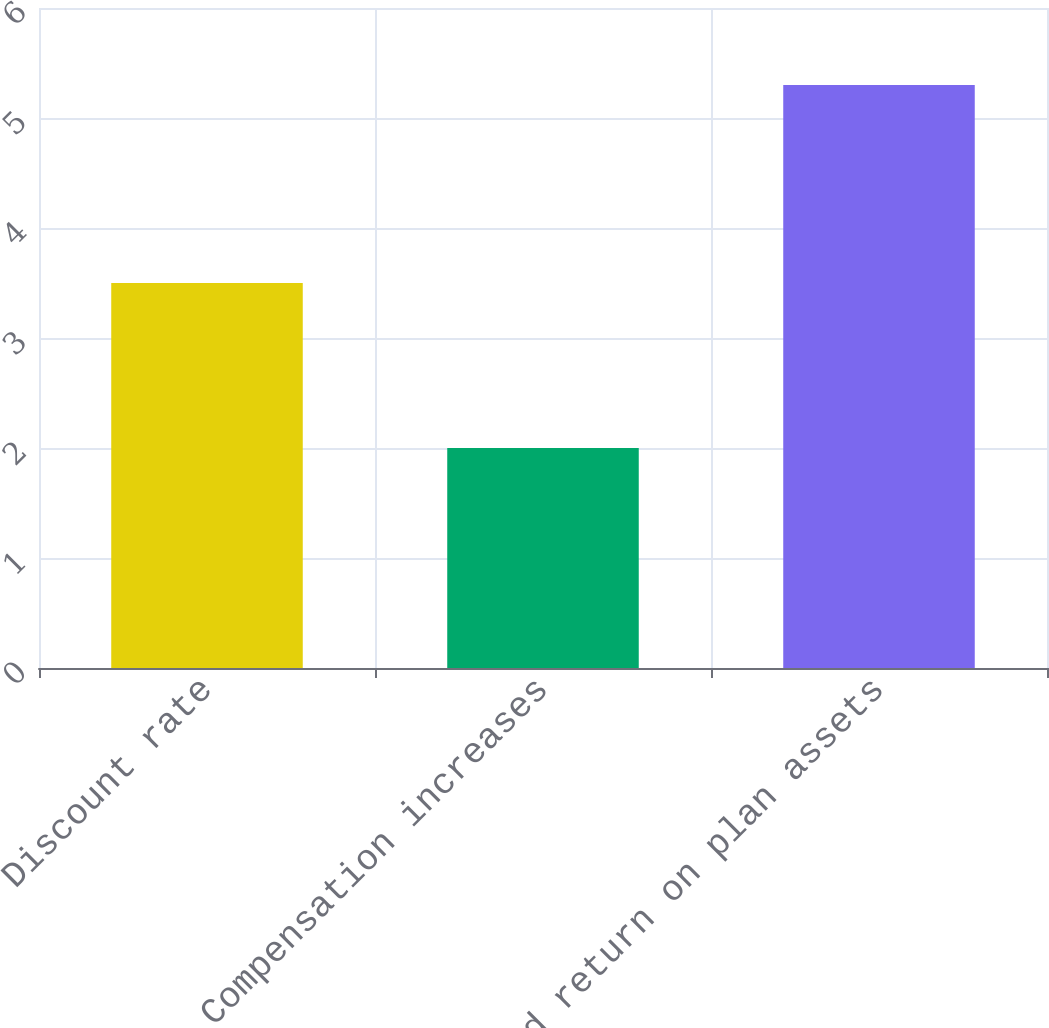Convert chart. <chart><loc_0><loc_0><loc_500><loc_500><bar_chart><fcel>Discount rate<fcel>Compensation increases<fcel>Expected return on plan assets<nl><fcel>3.5<fcel>2<fcel>5.3<nl></chart> 